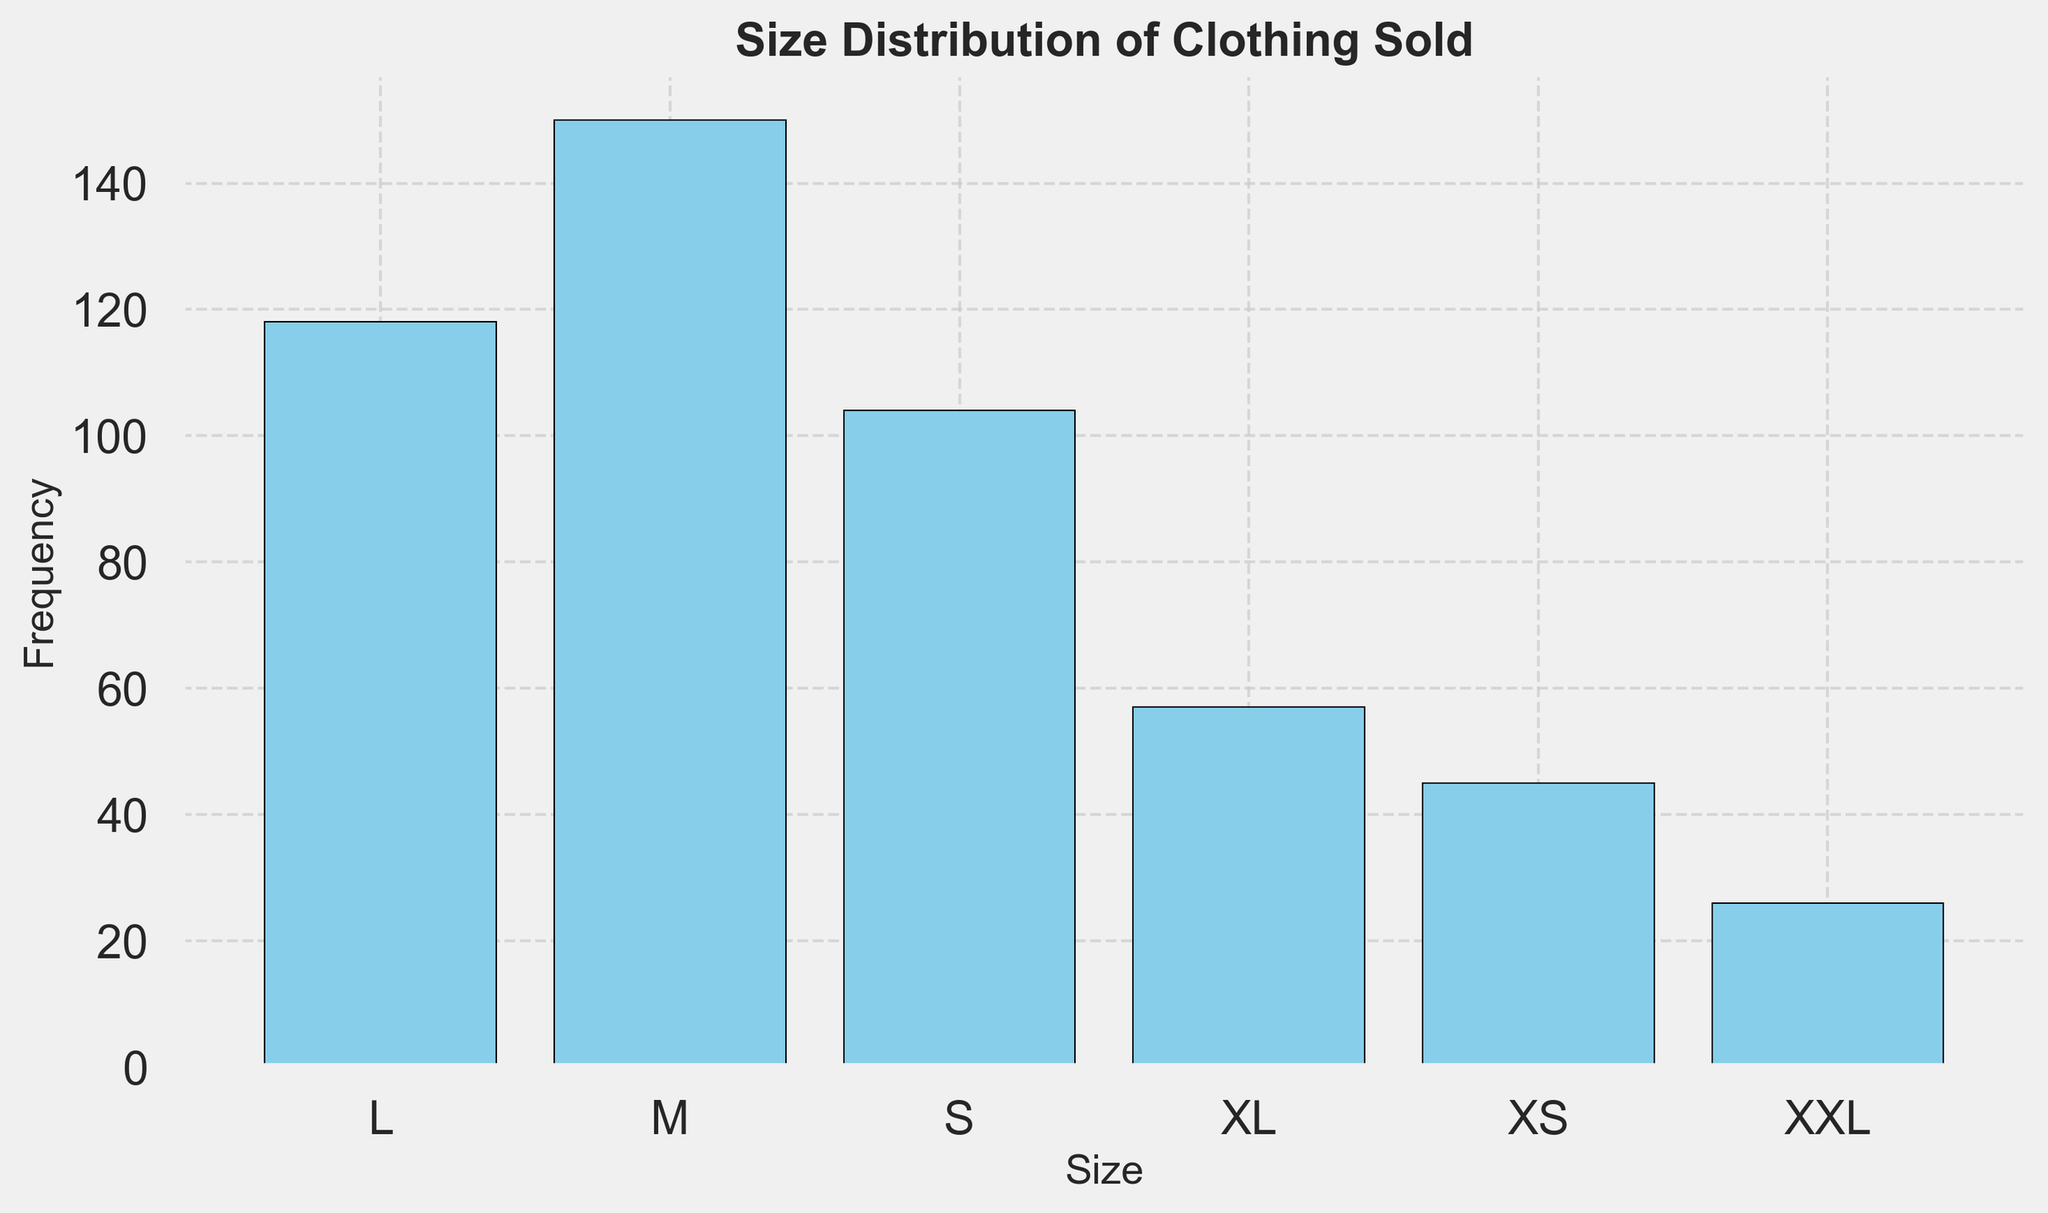How many total items of size "M" were sold? The figure shows the frequencies for each size. To find the total for "M," sum up all the frequencies corresponding to "M": 40 + 35 + 38 + 37.
Answer: 150 Which size had the highest frequency? By comparing the heights of the bars, we see that "M" has the highest bar, indicating the highest frequency.
Answer: M What is the total frequency of sizes "L" and "XL" combined? Add the frequencies for "L" and "XL" together. The total for "L" = 30 + 25 + 32 + 31 and the total for "XL" = 15 + 10 + 18 + 14. Adding these gives us (30 + 25 + 32 + 31) + (15 + 10 + 18 + 14).
Answer: 175 Which size had the least frequency? The shortest bar represents the lowest frequency. Here, "XXL" has the shortest bar.
Answer: XXL What is the average frequency of size "S"? Calculate the average by summing all the frequencies for "S" and then dividing by the number of entries: (25 + 28 + 24 + 27) / 4.
Answer: 26 What is the difference in frequency between size "M" and size "XS"? Find the total frequency for both sizes and subtract: Frequency of "M" = 150 and "XS" = 45. The difference is 150 - 45.
Answer: 105 Which size has a frequency closest to 30? Observe the bars and measure the one closest to a height of 30. L has a frequency summing up to 30 + 25 + 32 + 31, which averages closer to 30.
Answer: L Compare the total frequency of size "S" with "XL." Which one is greater? Calculate the sums for each size: S = 104 and XL = 57. Then compare these totals.
Answer: S How many more items of size "M" were sold than size "L"? Total items sold for "M" = 150 and total items for "L" = 118. Subtract the total of "L" from "M".
Answer: 32 What is the combined frequency of the two most frequently sold sizes? The two most frequently sold sizes are "M" and "L". Add their totals: 150 ("M") + 118 ("L").
Answer: 268 